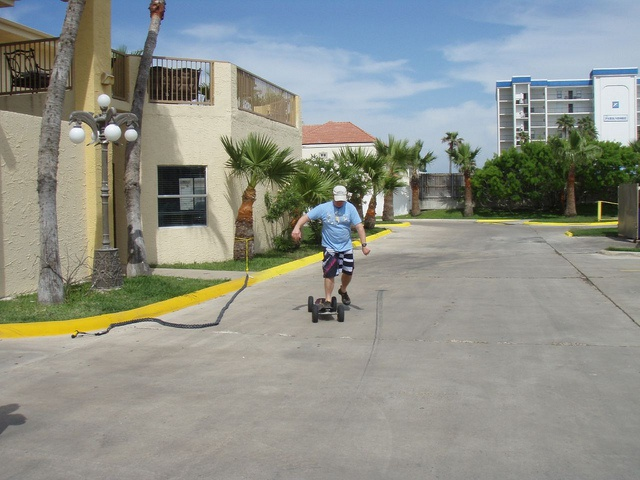Describe the objects in this image and their specific colors. I can see people in gray, lightblue, and black tones, bench in gray and black tones, chair in gray and black tones, skateboard in gray, black, and darkgray tones, and clock in gray and brown tones in this image. 